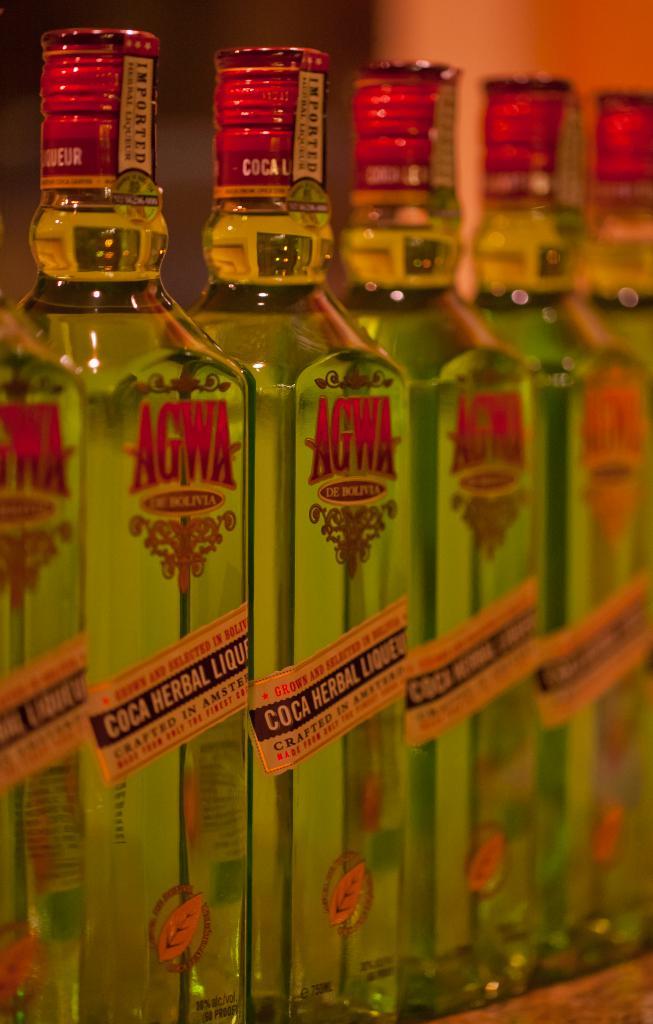What is the brand name on the bottle?
Ensure brevity in your answer.  Agwa. 